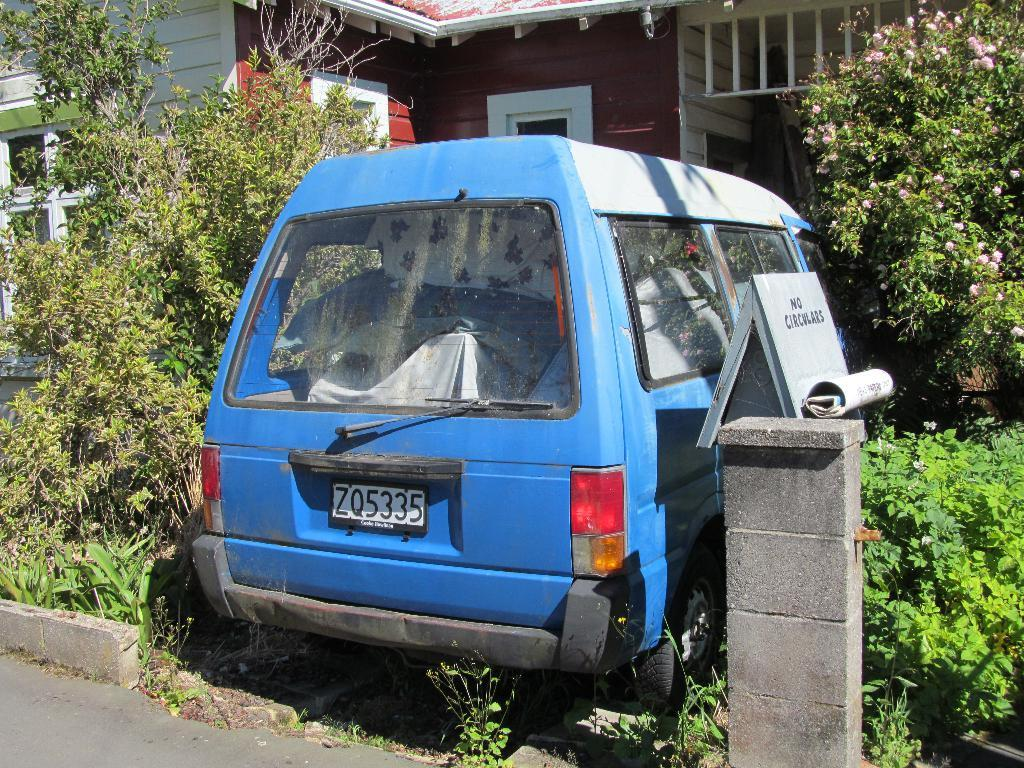<image>
Describe the image concisely. An old blue vehicle has the license plate number ZQ5335. 